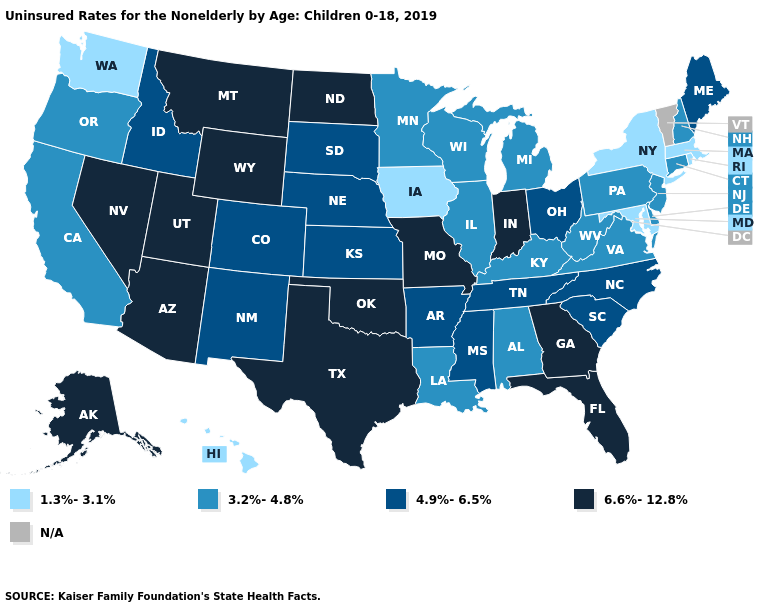What is the value of Pennsylvania?
Write a very short answer. 3.2%-4.8%. Name the states that have a value in the range 6.6%-12.8%?
Concise answer only. Alaska, Arizona, Florida, Georgia, Indiana, Missouri, Montana, Nevada, North Dakota, Oklahoma, Texas, Utah, Wyoming. Is the legend a continuous bar?
Quick response, please. No. Among the states that border Utah , which have the highest value?
Concise answer only. Arizona, Nevada, Wyoming. What is the value of New Mexico?
Concise answer only. 4.9%-6.5%. What is the highest value in the Northeast ?
Quick response, please. 4.9%-6.5%. Does Wyoming have the highest value in the USA?
Write a very short answer. Yes. Does the first symbol in the legend represent the smallest category?
Be succinct. Yes. What is the value of Tennessee?
Answer briefly. 4.9%-6.5%. Does Pennsylvania have the lowest value in the USA?
Give a very brief answer. No. What is the lowest value in the USA?
Quick response, please. 1.3%-3.1%. Among the states that border Arizona , does Utah have the lowest value?
Keep it brief. No. 